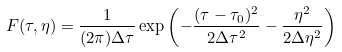Convert formula to latex. <formula><loc_0><loc_0><loc_500><loc_500>F ( \tau , \eta ) = \frac { 1 } { ( 2 \pi ) \Delta \tau } \exp \left ( - \frac { ( \tau - \tau _ { 0 } ) ^ { 2 } } { 2 \Delta \tau ^ { 2 } } - \frac { \eta ^ { 2 } } { 2 \Delta \eta ^ { 2 } } \right )</formula> 